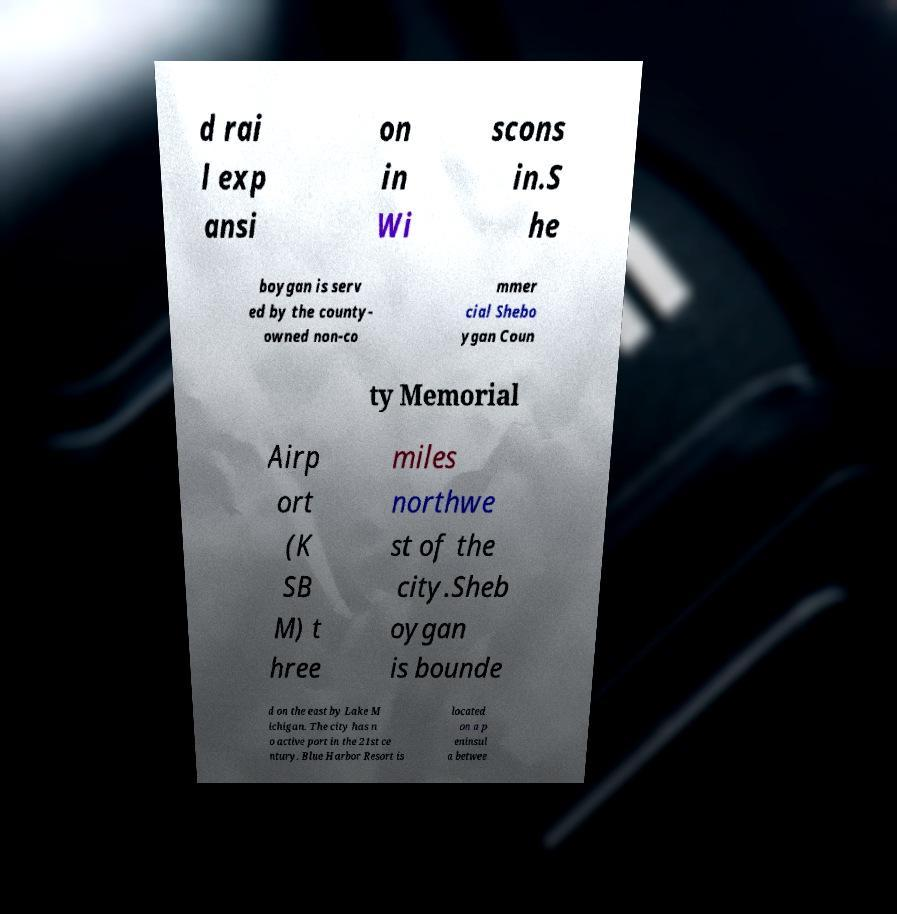Please read and relay the text visible in this image. What does it say? d rai l exp ansi on in Wi scons in.S he boygan is serv ed by the county- owned non-co mmer cial Shebo ygan Coun ty Memorial Airp ort (K SB M) t hree miles northwe st of the city.Sheb oygan is bounde d on the east by Lake M ichigan. The city has n o active port in the 21st ce ntury. Blue Harbor Resort is located on a p eninsul a betwee 